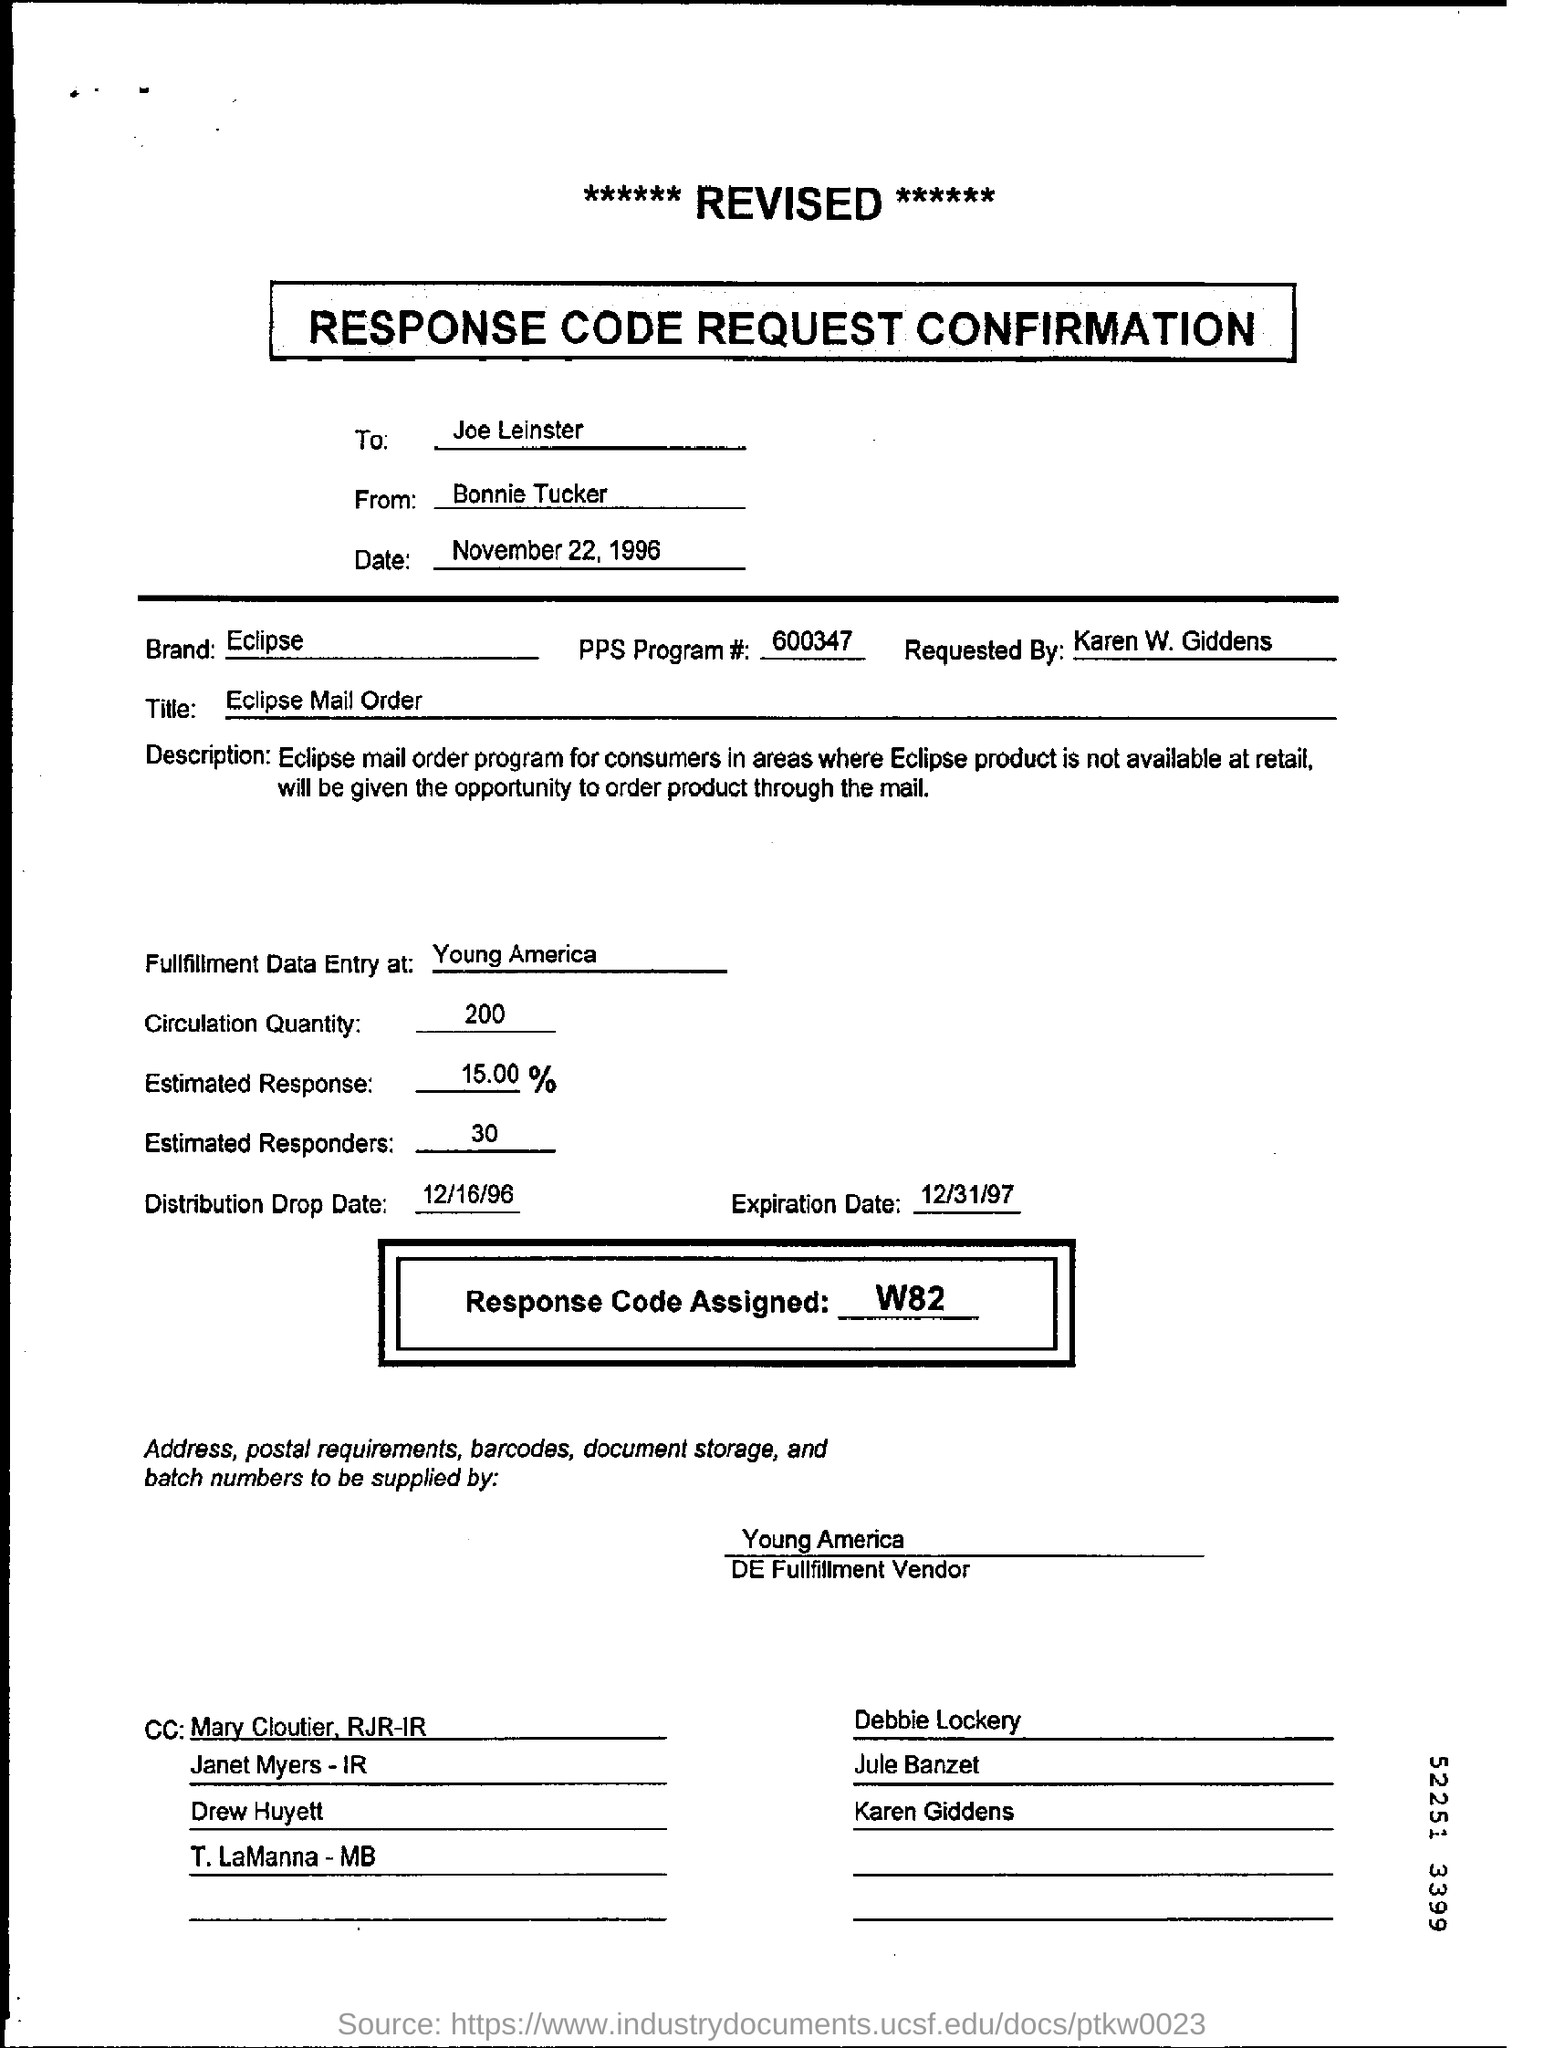To whom is this document addressed?
Your response must be concise. Joe Leinster. What is the date mentioned?
Give a very brief answer. November 22, 1996. 